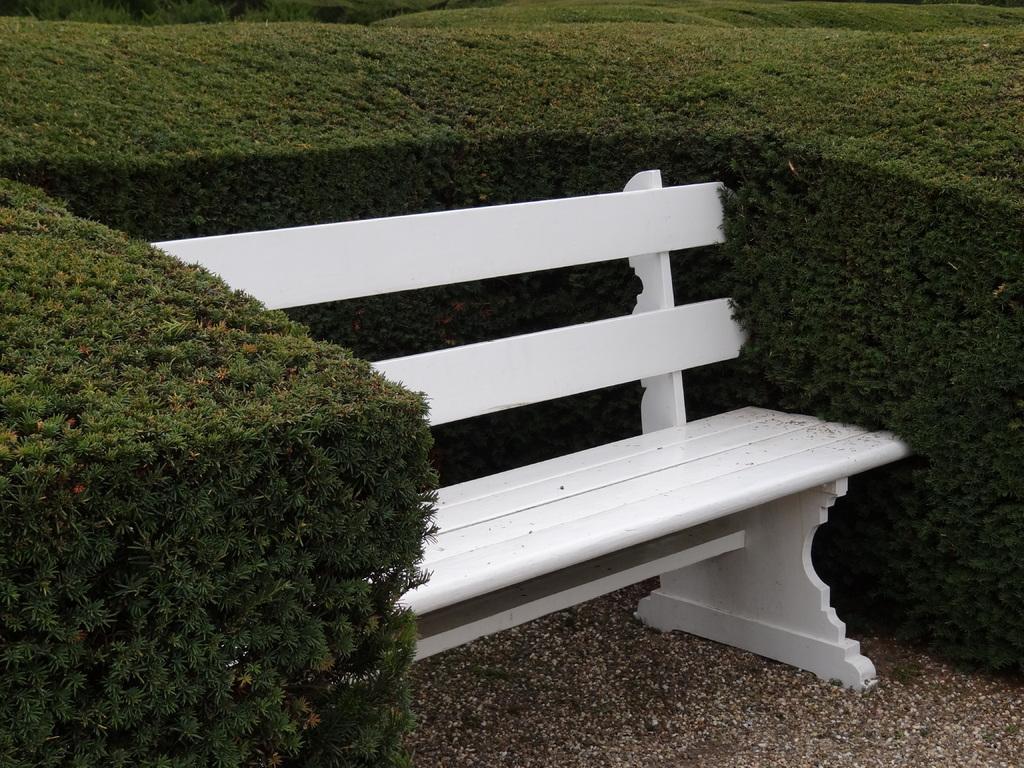In one or two sentences, can you explain what this image depicts? In this image I can see a white colored bench on the ground. I can see few plants which are green in color around the bench. 